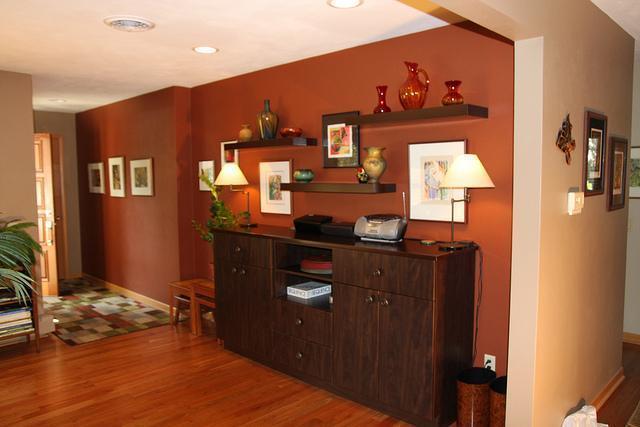How many chairs can be seen?
Give a very brief answer. 1. 